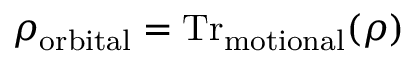Convert formula to latex. <formula><loc_0><loc_0><loc_500><loc_500>\rho _ { o r b i t a l } = T r _ { m o t i o n a l } ( \rho )</formula> 